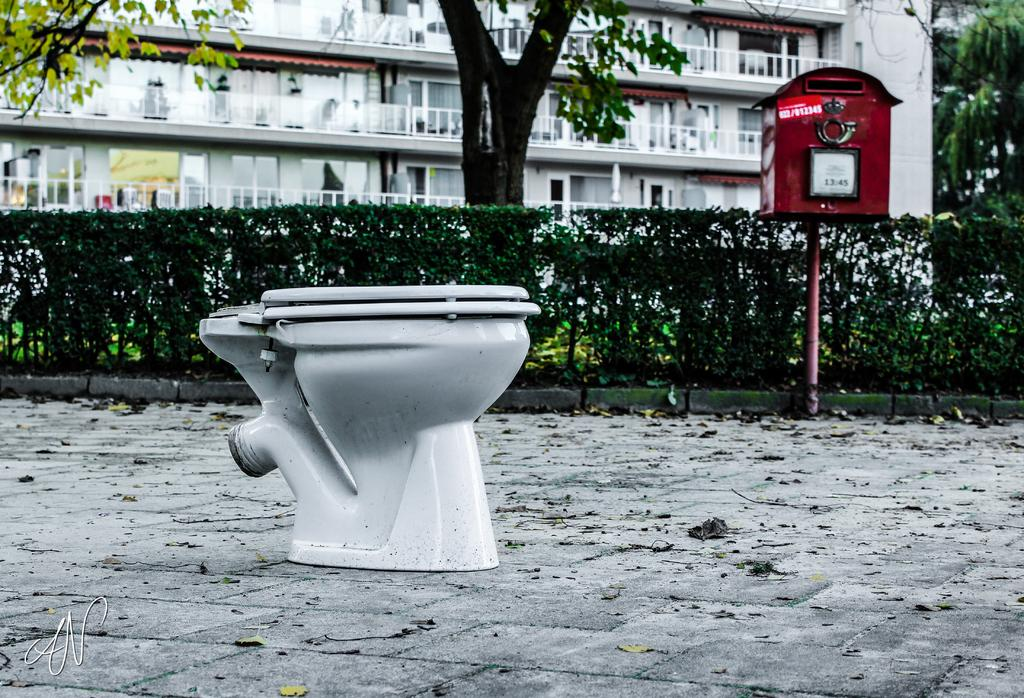What is the main object in the foreground of the image? There is a pot in the foreground of the image. What can be seen in the background of the image? In the background of the image, there are plants, a letterbox, trees, and buildings. What is present on the ground in the image? Dried leaves are present on the ground in the image. What type of button can be seen on the bird in the image? There is no bird present in the image, so there is no button to be seen on a bird. 